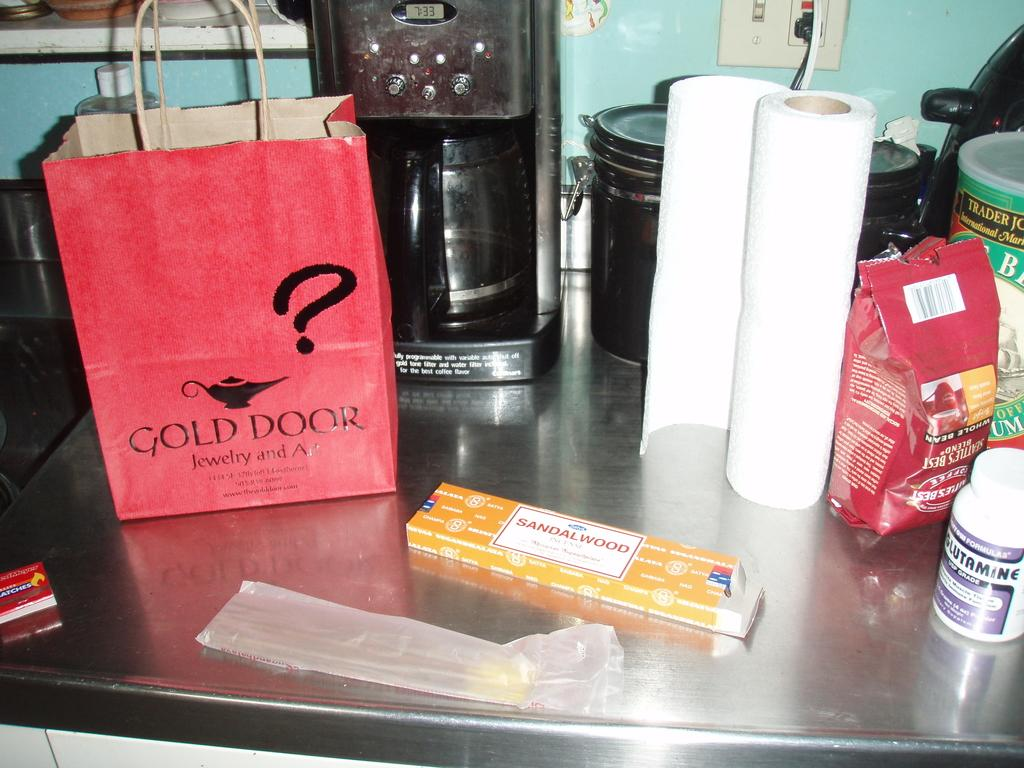<image>
Offer a succinct explanation of the picture presented. A pink gift bag from Gold Door Jewelry and Art sits on a silver counter top next to other items like coffee maker and paper towels. 